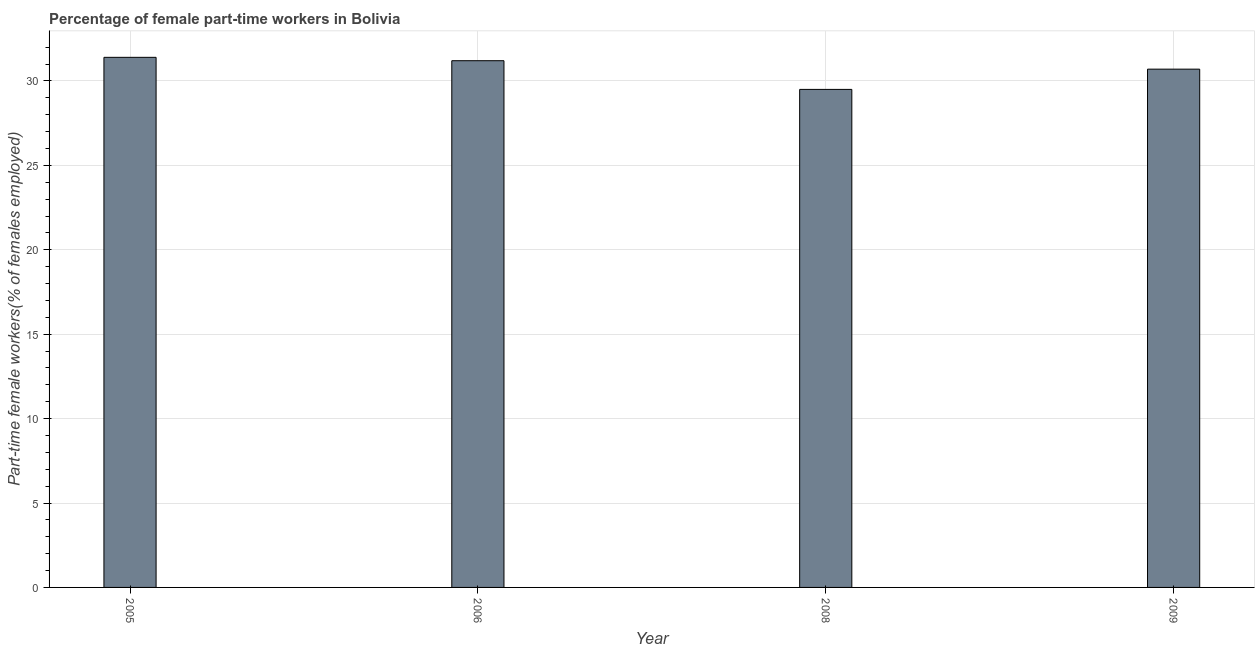What is the title of the graph?
Give a very brief answer. Percentage of female part-time workers in Bolivia. What is the label or title of the Y-axis?
Offer a very short reply. Part-time female workers(% of females employed). What is the percentage of part-time female workers in 2009?
Provide a succinct answer. 30.7. Across all years, what is the maximum percentage of part-time female workers?
Provide a short and direct response. 31.4. Across all years, what is the minimum percentage of part-time female workers?
Provide a short and direct response. 29.5. In which year was the percentage of part-time female workers maximum?
Your answer should be very brief. 2005. In which year was the percentage of part-time female workers minimum?
Keep it short and to the point. 2008. What is the sum of the percentage of part-time female workers?
Your answer should be compact. 122.8. What is the average percentage of part-time female workers per year?
Offer a terse response. 30.7. What is the median percentage of part-time female workers?
Make the answer very short. 30.95. In how many years, is the percentage of part-time female workers greater than 26 %?
Give a very brief answer. 4. Do a majority of the years between 2009 and 2006 (inclusive) have percentage of part-time female workers greater than 23 %?
Offer a very short reply. Yes. What is the ratio of the percentage of part-time female workers in 2005 to that in 2006?
Your answer should be very brief. 1.01. Is the difference between the percentage of part-time female workers in 2006 and 2009 greater than the difference between any two years?
Your response must be concise. No. What is the difference between the highest and the lowest percentage of part-time female workers?
Make the answer very short. 1.9. Are all the bars in the graph horizontal?
Keep it short and to the point. No. How many years are there in the graph?
Your response must be concise. 4. What is the Part-time female workers(% of females employed) in 2005?
Provide a succinct answer. 31.4. What is the Part-time female workers(% of females employed) of 2006?
Keep it short and to the point. 31.2. What is the Part-time female workers(% of females employed) of 2008?
Ensure brevity in your answer.  29.5. What is the Part-time female workers(% of females employed) in 2009?
Your answer should be very brief. 30.7. What is the difference between the Part-time female workers(% of females employed) in 2005 and 2006?
Give a very brief answer. 0.2. What is the difference between the Part-time female workers(% of females employed) in 2005 and 2008?
Keep it short and to the point. 1.9. What is the difference between the Part-time female workers(% of females employed) in 2006 and 2009?
Make the answer very short. 0.5. What is the ratio of the Part-time female workers(% of females employed) in 2005 to that in 2006?
Ensure brevity in your answer.  1.01. What is the ratio of the Part-time female workers(% of females employed) in 2005 to that in 2008?
Your answer should be very brief. 1.06. What is the ratio of the Part-time female workers(% of females employed) in 2005 to that in 2009?
Your answer should be very brief. 1.02. What is the ratio of the Part-time female workers(% of females employed) in 2006 to that in 2008?
Your response must be concise. 1.06. 